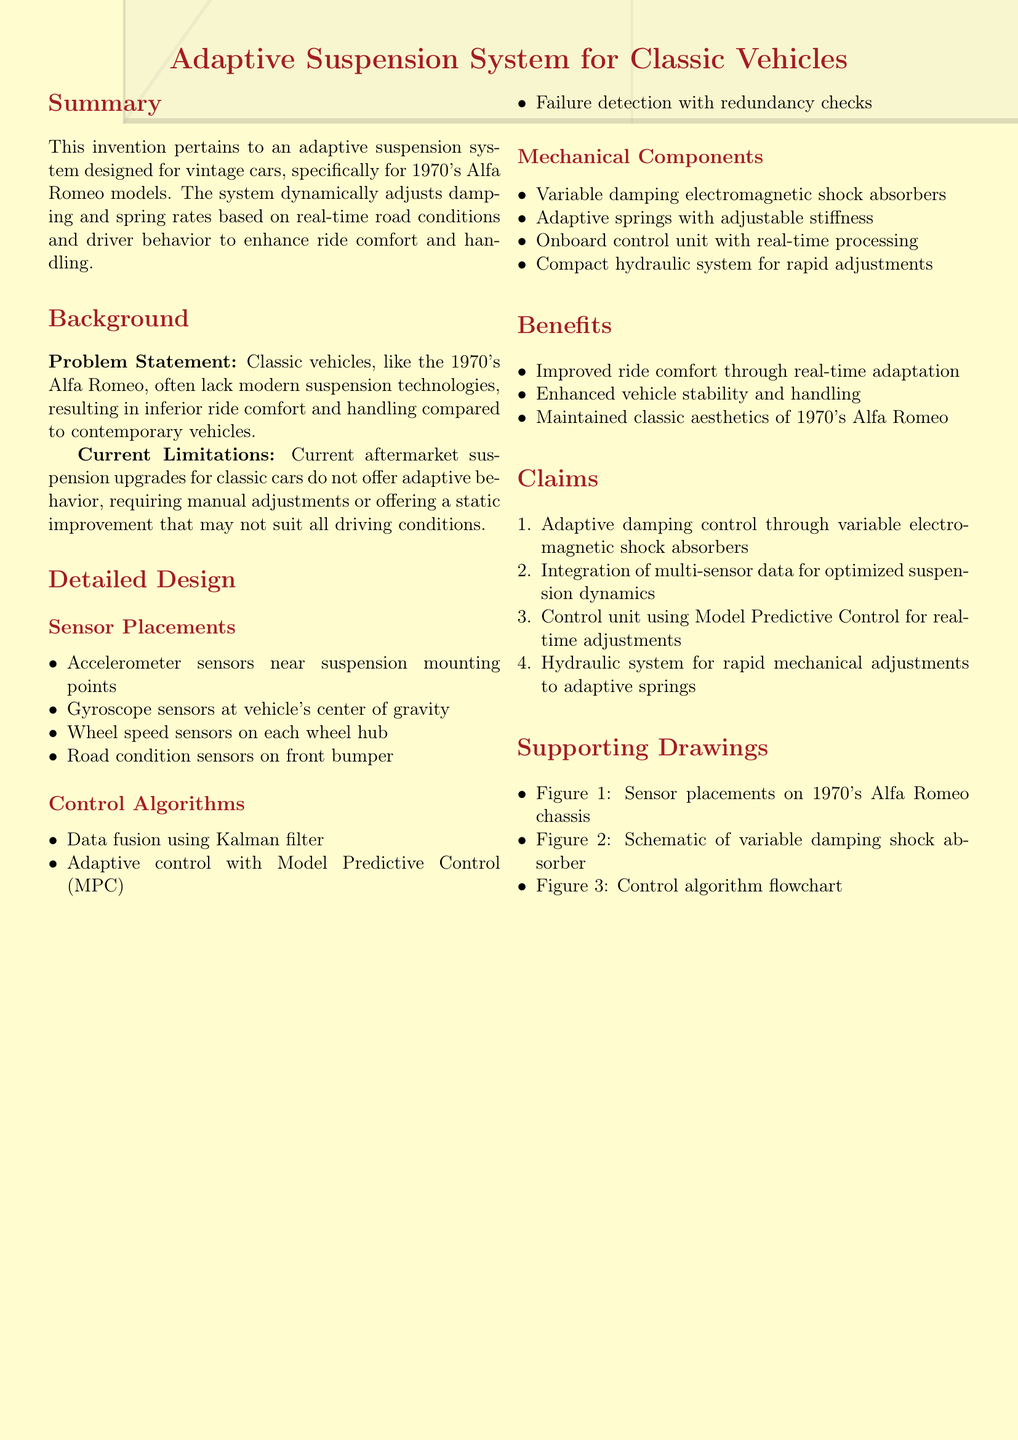What is the title of the invention? The title of the invention is provided at the beginning of the document and indicates the subject matter being patented.
Answer: Adaptive Suspension System for Classic Vehicles What decade are the targeted vintage cars from? The document specifies the classic vehicles targeted by the invention, particularly identifying the decade.
Answer: 1970's What type of sensors are placed on the vehicle's front bumper? The document lists the types of sensors used in the adaptive suspension system, highlighting those located on the front bumper.
Answer: Road condition sensors What control method is utilized for adaptive control? The document mentions the specific control algorithm employed for adapting the system to real-time conditions.
Answer: Model Predictive Control (MPC) How many claims are outlined in the patent application? The number of claims is indicated in the Claims section of the document, signifying the protections sought.
Answer: Four What is the main benefit of improved ride comfort? The document discusses the advantages of real-time adaptation of the suspension, identifying improved ride comfort as a key benefit.
Answer: Real-time adaptation Which specific component provides rapid adjustments? The document lists various mechanical components of the suspension system, pointing out which one offers quick mechanical changes.
Answer: Hydraulic system What type of control does the unit use for real-time adjustments? The document addresses the functionality of the onboard control unit, specifying the method used for real-time control.
Answer: Model Predictive Control What is the primary design focus of the system? The document explains the main objective of the adaptive suspension system in relation to vintage cars, especially in terms of user experience.
Answer: Enhance ride comfort and handling 